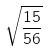<formula> <loc_0><loc_0><loc_500><loc_500>\sqrt { \frac { 1 5 } { 5 6 } }</formula> 